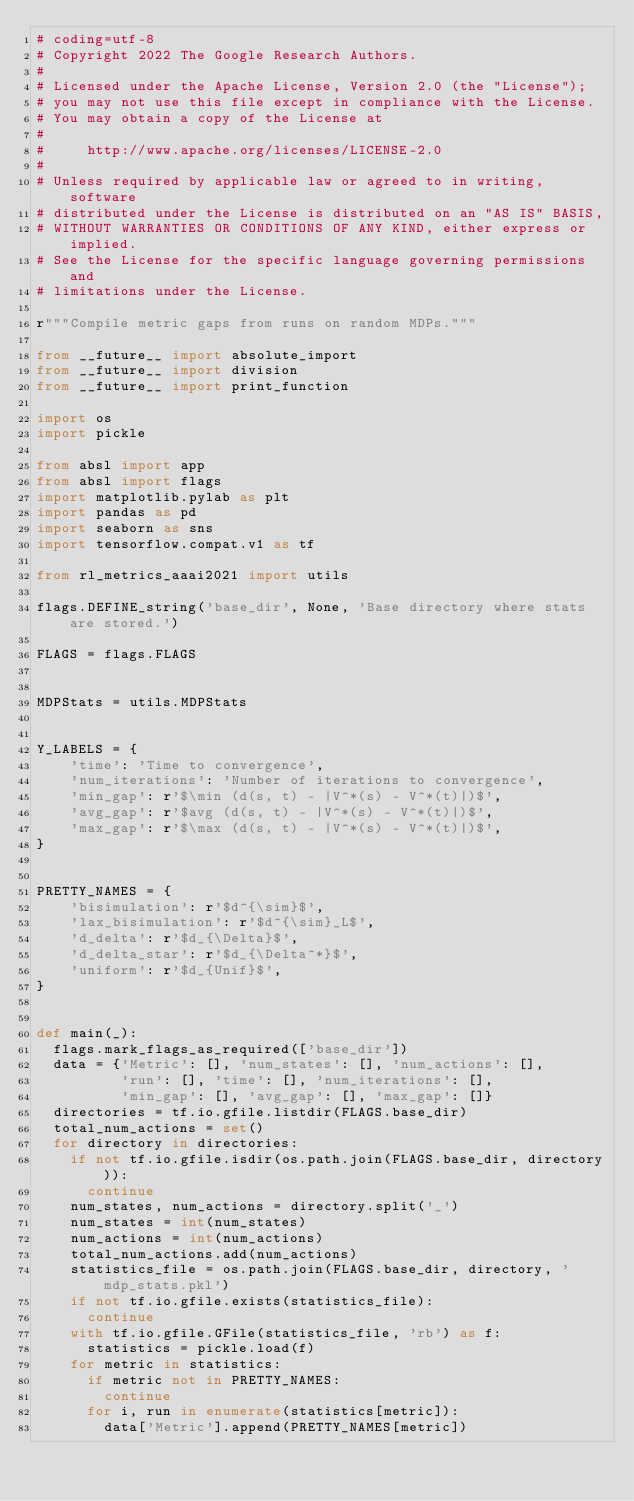Convert code to text. <code><loc_0><loc_0><loc_500><loc_500><_Python_># coding=utf-8
# Copyright 2022 The Google Research Authors.
#
# Licensed under the Apache License, Version 2.0 (the "License");
# you may not use this file except in compliance with the License.
# You may obtain a copy of the License at
#
#     http://www.apache.org/licenses/LICENSE-2.0
#
# Unless required by applicable law or agreed to in writing, software
# distributed under the License is distributed on an "AS IS" BASIS,
# WITHOUT WARRANTIES OR CONDITIONS OF ANY KIND, either express or implied.
# See the License for the specific language governing permissions and
# limitations under the License.

r"""Compile metric gaps from runs on random MDPs."""

from __future__ import absolute_import
from __future__ import division
from __future__ import print_function

import os
import pickle

from absl import app
from absl import flags
import matplotlib.pylab as plt
import pandas as pd
import seaborn as sns
import tensorflow.compat.v1 as tf

from rl_metrics_aaai2021 import utils

flags.DEFINE_string('base_dir', None, 'Base directory where stats are stored.')

FLAGS = flags.FLAGS


MDPStats = utils.MDPStats


Y_LABELS = {
    'time': 'Time to convergence',
    'num_iterations': 'Number of iterations to convergence',
    'min_gap': r'$\min (d(s, t) - |V^*(s) - V^*(t)|)$',
    'avg_gap': r'$avg (d(s, t) - |V^*(s) - V^*(t)|)$',
    'max_gap': r'$\max (d(s, t) - |V^*(s) - V^*(t)|)$',
}


PRETTY_NAMES = {
    'bisimulation': r'$d^{\sim}$',
    'lax_bisimulation': r'$d^{\sim}_L$',
    'd_delta': r'$d_{\Delta}$',
    'd_delta_star': r'$d_{\Delta^*}$',
    'uniform': r'$d_{Unif}$',
}


def main(_):
  flags.mark_flags_as_required(['base_dir'])
  data = {'Metric': [], 'num_states': [], 'num_actions': [],
          'run': [], 'time': [], 'num_iterations': [],
          'min_gap': [], 'avg_gap': [], 'max_gap': []}
  directories = tf.io.gfile.listdir(FLAGS.base_dir)
  total_num_actions = set()
  for directory in directories:
    if not tf.io.gfile.isdir(os.path.join(FLAGS.base_dir, directory)):
      continue
    num_states, num_actions = directory.split('_')
    num_states = int(num_states)
    num_actions = int(num_actions)
    total_num_actions.add(num_actions)
    statistics_file = os.path.join(FLAGS.base_dir, directory, 'mdp_stats.pkl')
    if not tf.io.gfile.exists(statistics_file):
      continue
    with tf.io.gfile.GFile(statistics_file, 'rb') as f:
      statistics = pickle.load(f)
    for metric in statistics:
      if metric not in PRETTY_NAMES:
        continue
      for i, run in enumerate(statistics[metric]):
        data['Metric'].append(PRETTY_NAMES[metric])</code> 